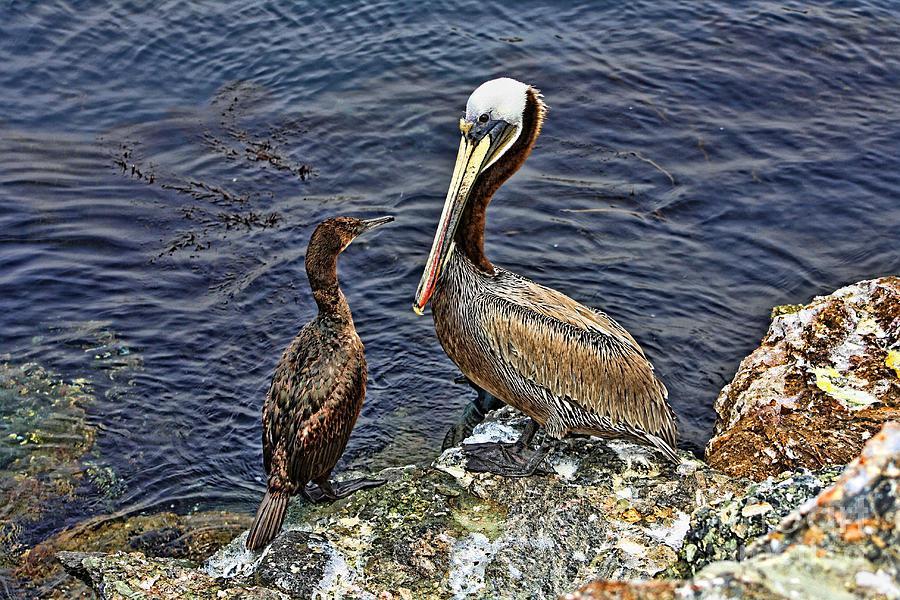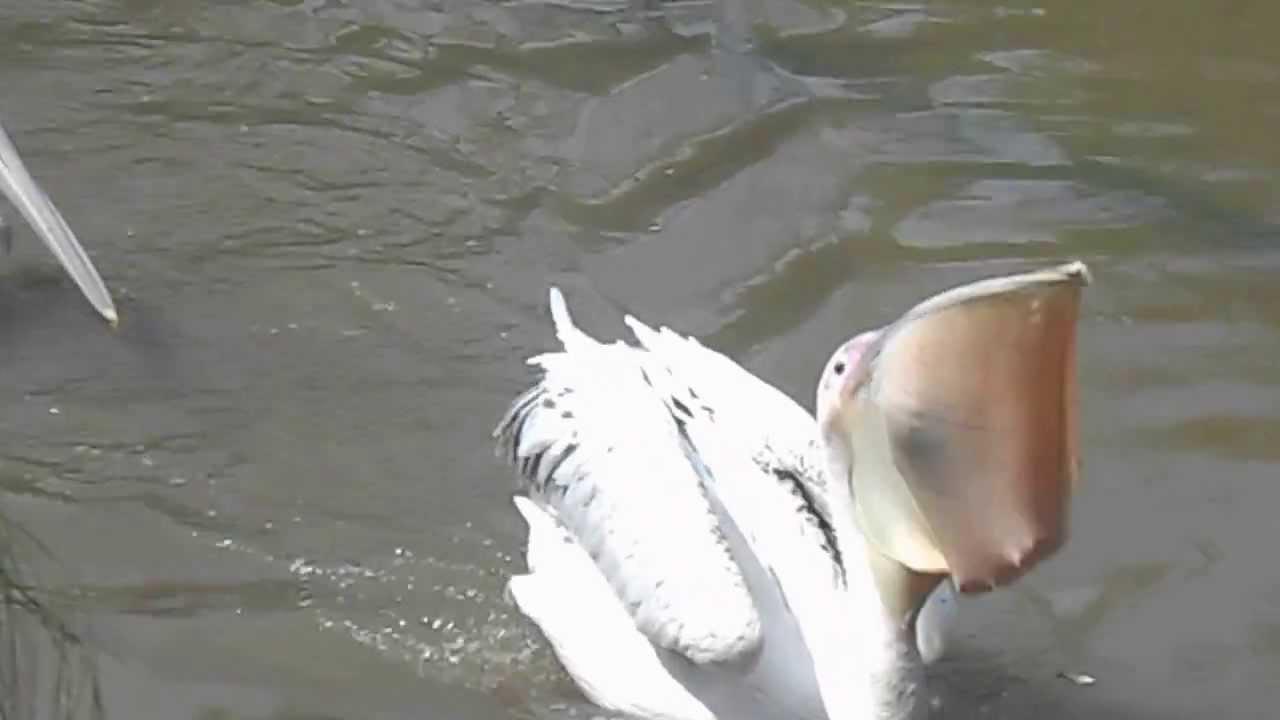The first image is the image on the left, the second image is the image on the right. Given the left and right images, does the statement "There a single bird with black and white feathers facing left." hold true? Answer yes or no. No. The first image is the image on the left, the second image is the image on the right. Examine the images to the left and right. Is the description "The bird in the left image has a fish in it's beak." accurate? Answer yes or no. No. 